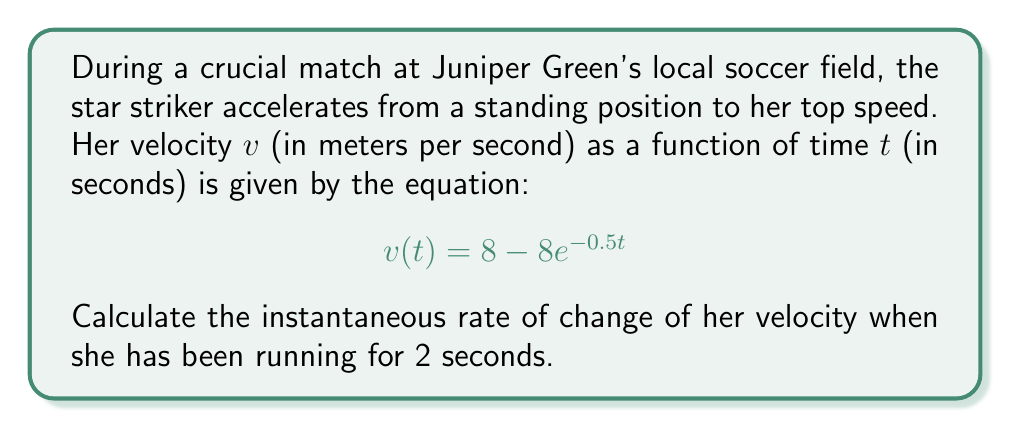Show me your answer to this math problem. To find the instantaneous rate of change of velocity at $t = 2$ seconds, we need to find the derivative of the velocity function and evaluate it at $t = 2$.

1) The velocity function is given as:
   $$v(t) = 8 - 8e^{-0.5t}$$

2) To find the derivative, we use the chain rule:
   $$\frac{dv}{dt} = 0 - 8 \cdot \frac{d}{dt}(e^{-0.5t})$$
   $$\frac{dv}{dt} = -8 \cdot (-0.5) \cdot e^{-0.5t}$$
   $$\frac{dv}{dt} = 4e^{-0.5t}$$

3) This derivative represents the instantaneous rate of change of velocity, or acceleration.

4) Now, we evaluate this at $t = 2$:
   $$\frac{dv}{dt}\bigg|_{t=2} = 4e^{-0.5(2)}$$
   $$= 4e^{-1}$$
   $$\approx 1.47 \text{ m/s}^2$$

Therefore, after 2 seconds, the striker's acceleration (rate of change of velocity) is approximately 1.47 m/s².
Answer: $1.47 \text{ m/s}^2$ 